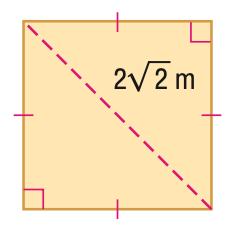Question: Find the area of the figure. Round to the nearest hundredth, if necessary.
Choices:
A. 4
B. 8
C. 16
D. 32
Answer with the letter. Answer: A 